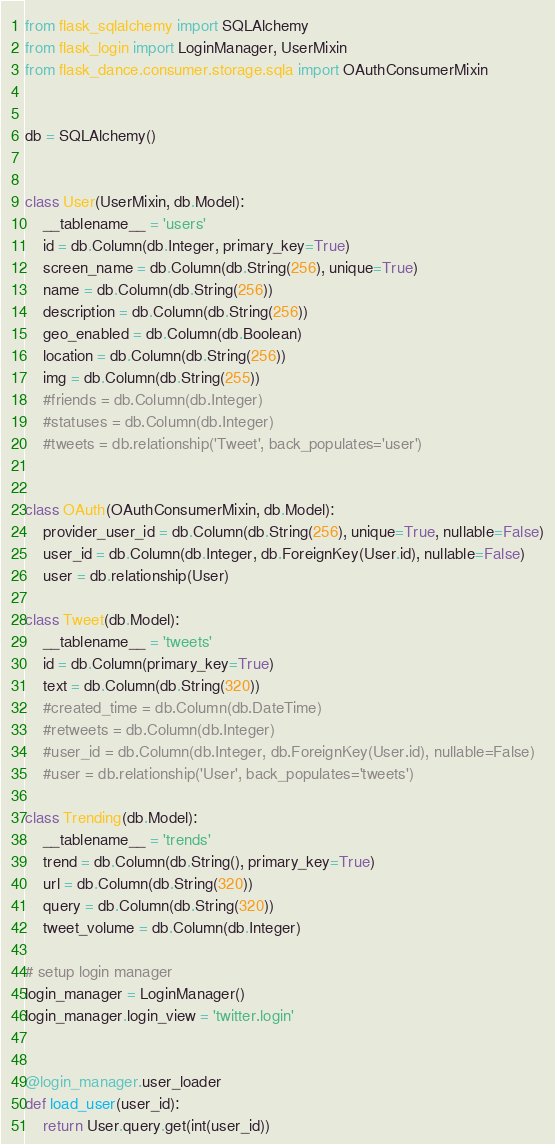<code> <loc_0><loc_0><loc_500><loc_500><_Python_>from flask_sqlalchemy import SQLAlchemy
from flask_login import LoginManager, UserMixin
from flask_dance.consumer.storage.sqla import OAuthConsumerMixin


db = SQLAlchemy()


class User(UserMixin, db.Model):
    __tablename__ = 'users'
    id = db.Column(db.Integer, primary_key=True)
    screen_name = db.Column(db.String(256), unique=True)
    name = db.Column(db.String(256))
    description = db.Column(db.String(256))
    geo_enabled = db.Column(db.Boolean)
    location = db.Column(db.String(256))
    img = db.Column(db.String(255))
    #friends = db.Column(db.Integer)
    #statuses = db.Column(db.Integer)
    #tweets = db.relationship('Tweet', back_populates='user')


class OAuth(OAuthConsumerMixin, db.Model):
    provider_user_id = db.Column(db.String(256), unique=True, nullable=False)
    user_id = db.Column(db.Integer, db.ForeignKey(User.id), nullable=False)
    user = db.relationship(User)

class Tweet(db.Model):
    __tablename__ = 'tweets'
    id = db.Column(primary_key=True)
    text = db.Column(db.String(320))
    #created_time = db.Column(db.DateTime)
    #retweets = db.Column(db.Integer)
    #user_id = db.Column(db.Integer, db.ForeignKey(User.id), nullable=False)
    #user = db.relationship('User', back_populates='tweets')

class Trending(db.Model):
    __tablename__ = 'trends'
    trend = db.Column(db.String(), primary_key=True)
    url = db.Column(db.String(320))
    query = db.Column(db.String(320))
    tweet_volume = db.Column(db.Integer)

# setup login manager
login_manager = LoginManager()
login_manager.login_view = 'twitter.login'


@login_manager.user_loader
def load_user(user_id):
    return User.query.get(int(user_id))</code> 